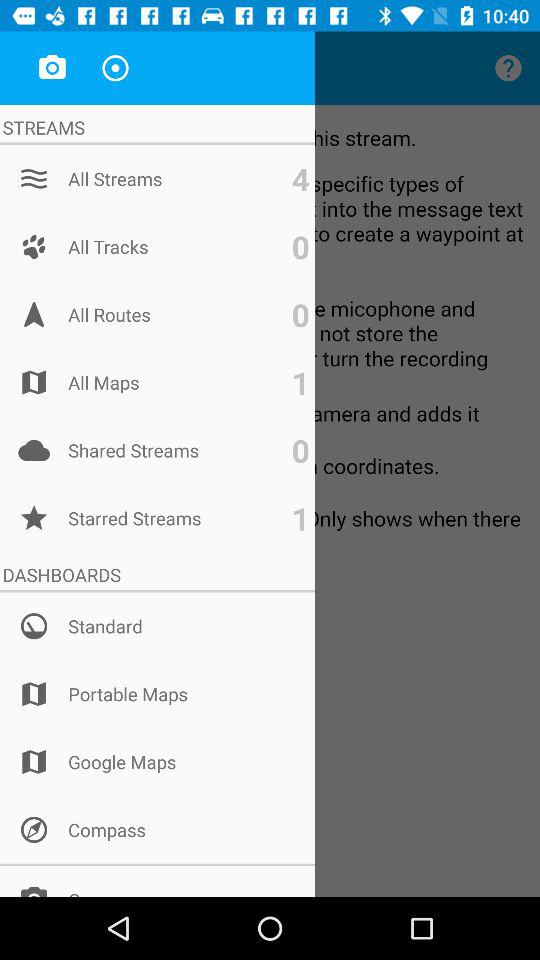What is the mentioned number for all maps? The mentioned number is 1. 